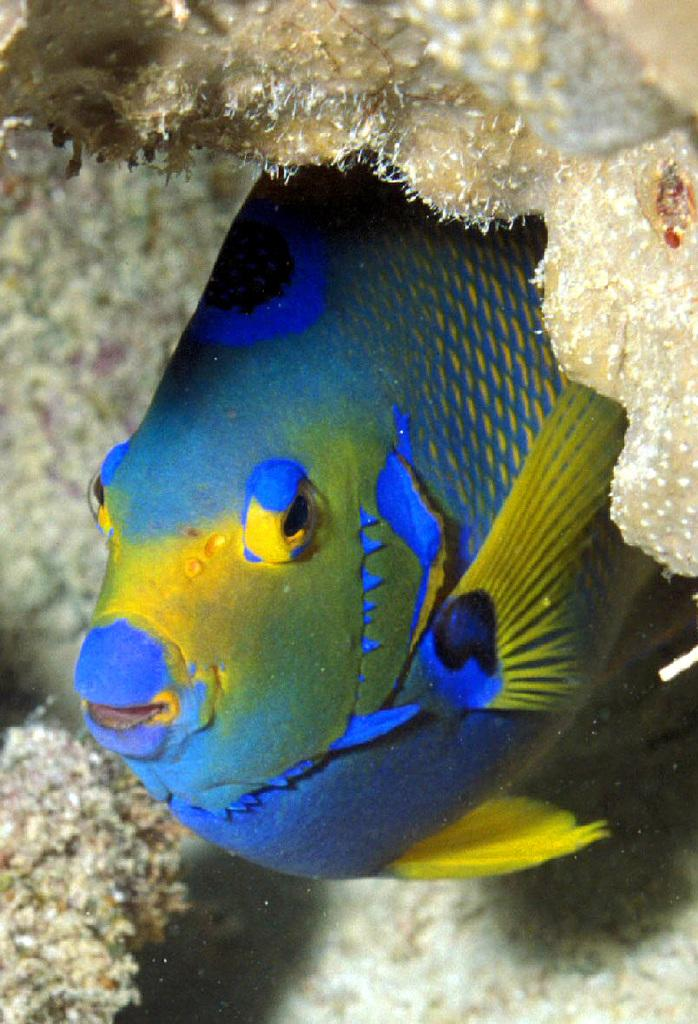What is the main subject of the image? There is a fish in the image. Where is the fish located in the image? The fish is in the center of the image. What colors can be seen on the fish? The fish is blue and yellow in color. What type of hydrant is visible in the image? There is no hydrant present in the image; it features a fish. What color are the trousers worn by the fish in the image? The image does not depict the fish wearing trousers, as fish do not wear clothing. 